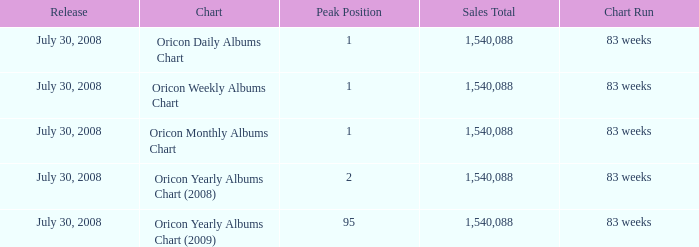How much Peak Position has Sales Total larger than 1,540,088? 0.0. Can you parse all the data within this table? {'header': ['Release', 'Chart', 'Peak Position', 'Sales Total', 'Chart Run'], 'rows': [['July 30, 2008', 'Oricon Daily Albums Chart', '1', '1,540,088', '83 weeks'], ['July 30, 2008', 'Oricon Weekly Albums Chart', '1', '1,540,088', '83 weeks'], ['July 30, 2008', 'Oricon Monthly Albums Chart', '1', '1,540,088', '83 weeks'], ['July 30, 2008', 'Oricon Yearly Albums Chart (2008)', '2', '1,540,088', '83 weeks'], ['July 30, 2008', 'Oricon Yearly Albums Chart (2009)', '95', '1,540,088', '83 weeks']]} 